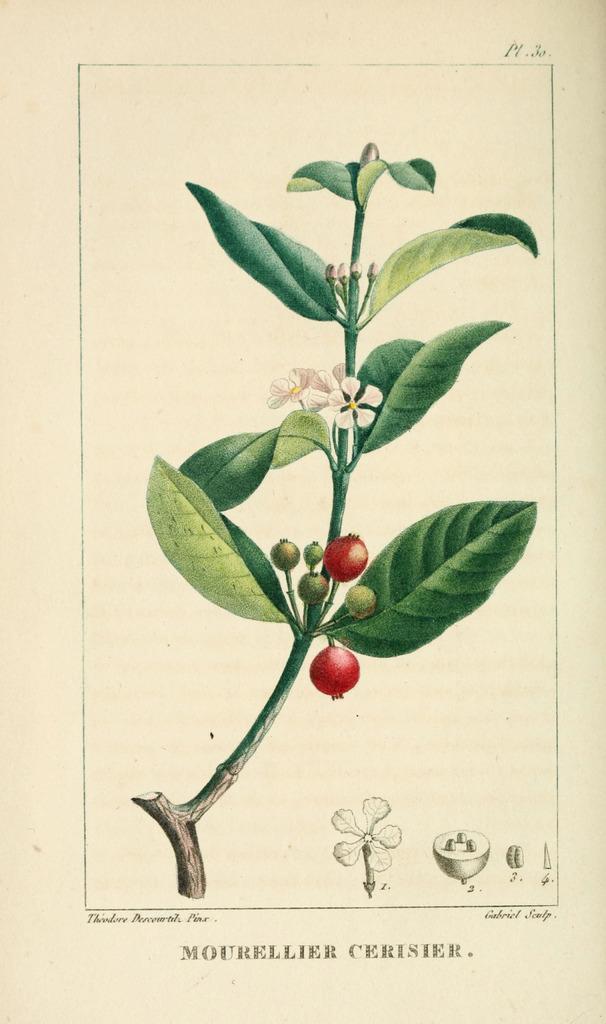Please provide a concise description of this image. In this picture we can see a poster, here we can see a plant with flowers, fruits and some text on it. 